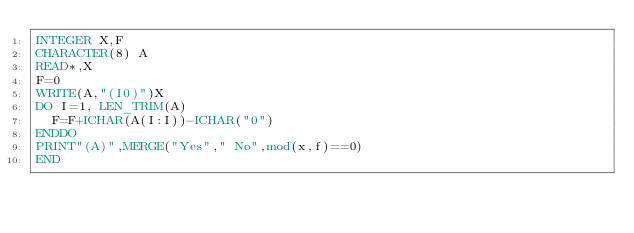Convert code to text. <code><loc_0><loc_0><loc_500><loc_500><_FORTRAN_>INTEGER X,F
CHARACTER(8) A
READ*,X
F=0
WRITE(A,"(I0)")X
DO I=1, LEN_TRIM(A)
	F=F+ICHAR(A(I:I))-ICHAR("0")
ENDDO
PRINT"(A)",MERGE("Yes"," No",mod(x,f)==0)
END</code> 